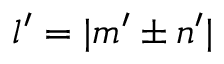<formula> <loc_0><loc_0><loc_500><loc_500>l ^ { \prime } = | m ^ { \prime } \pm n ^ { \prime } |</formula> 